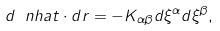<formula> <loc_0><loc_0><loc_500><loc_500>d \ n h a t \cdot d r = - K _ { \alpha \beta } d \xi ^ { \alpha } d \xi ^ { \beta } ,</formula> 